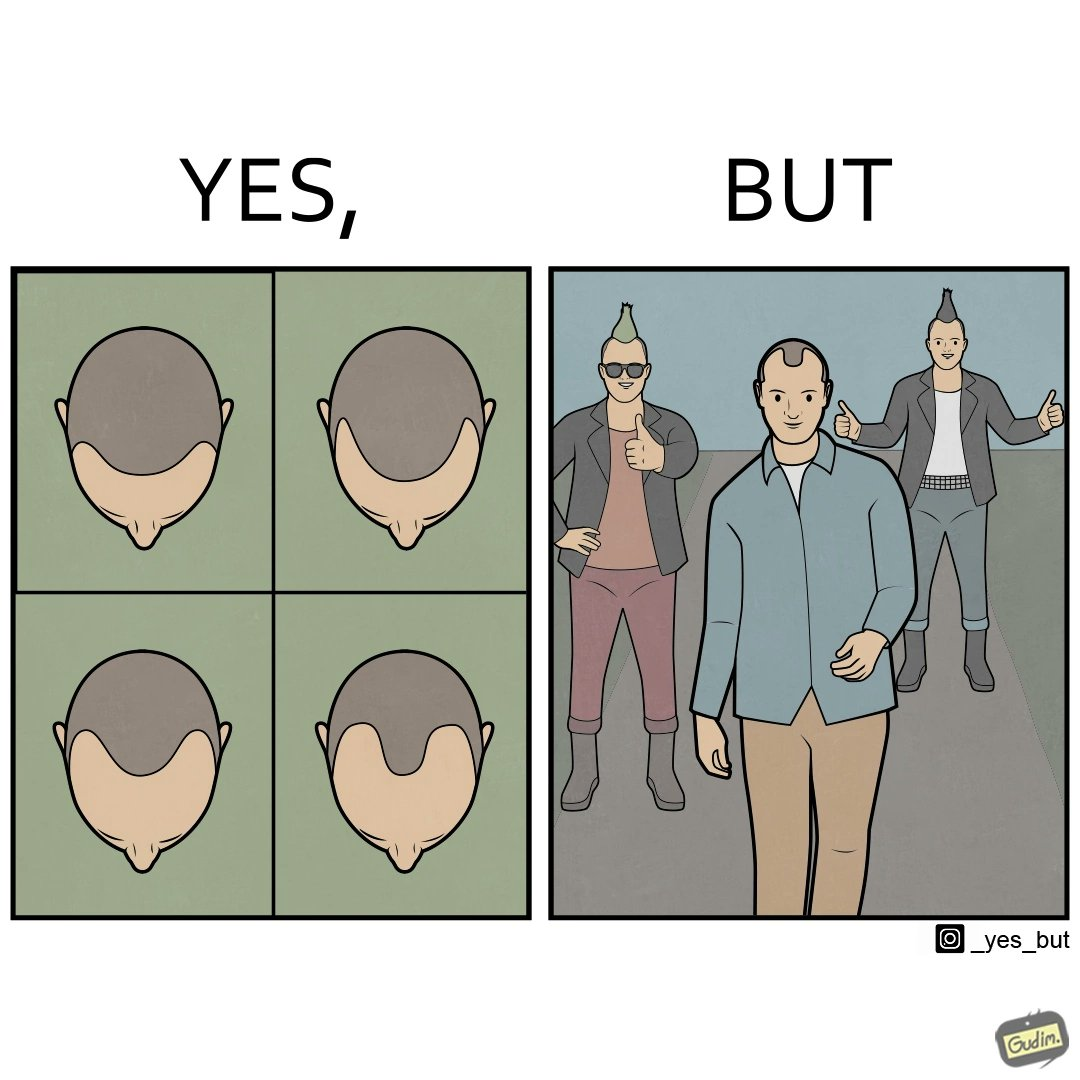Is this a satirical image? Yes, this image is satirical. 